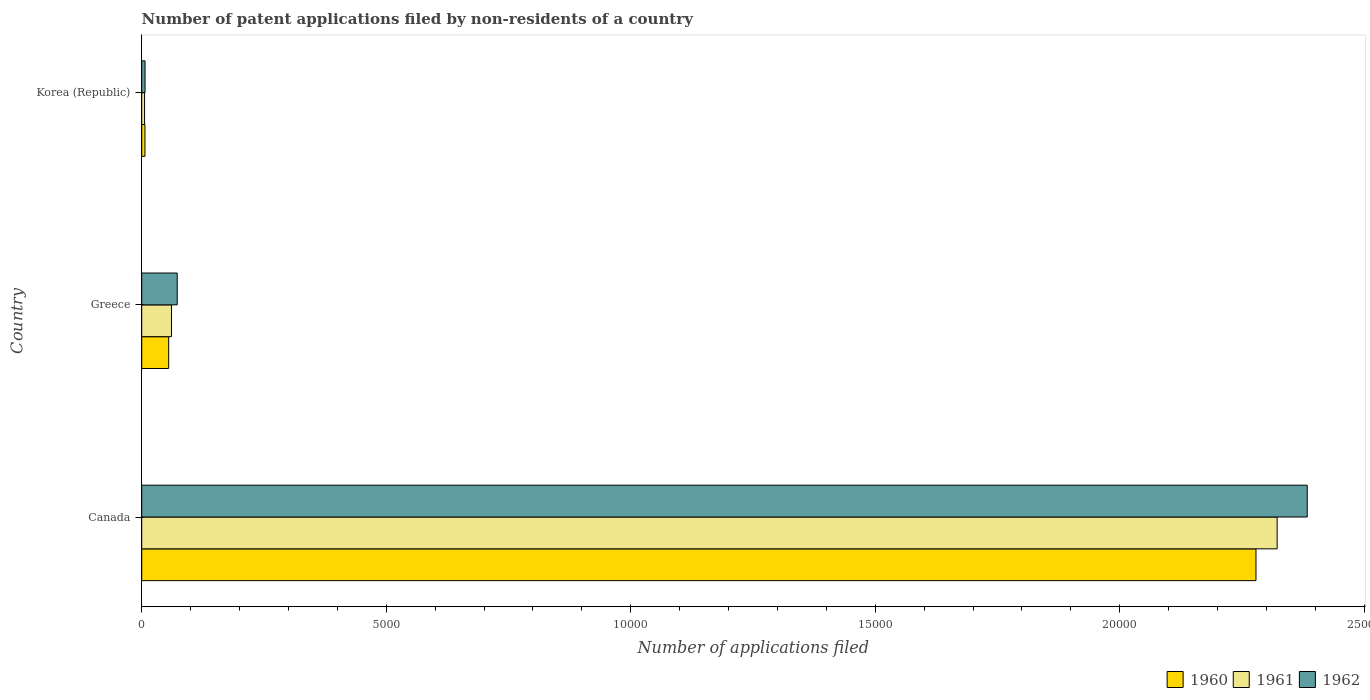Are the number of bars per tick equal to the number of legend labels?
Provide a short and direct response. Yes. How many bars are there on the 2nd tick from the bottom?
Ensure brevity in your answer.  3. What is the number of applications filed in 1961 in Greece?
Provide a succinct answer. 609. Across all countries, what is the maximum number of applications filed in 1960?
Offer a very short reply. 2.28e+04. In which country was the number of applications filed in 1961 minimum?
Keep it short and to the point. Korea (Republic). What is the total number of applications filed in 1962 in the graph?
Offer a terse response. 2.46e+04. What is the difference between the number of applications filed in 1960 in Canada and that in Korea (Republic)?
Your answer should be compact. 2.27e+04. What is the difference between the number of applications filed in 1961 in Canada and the number of applications filed in 1960 in Korea (Republic)?
Offer a terse response. 2.32e+04. What is the average number of applications filed in 1960 per country?
Your answer should be compact. 7801. What is the difference between the number of applications filed in 1961 and number of applications filed in 1962 in Korea (Republic)?
Offer a very short reply. -10. What is the ratio of the number of applications filed in 1962 in Canada to that in Greece?
Offer a very short reply. 32.83. What is the difference between the highest and the second highest number of applications filed in 1961?
Ensure brevity in your answer.  2.26e+04. What is the difference between the highest and the lowest number of applications filed in 1960?
Offer a terse response. 2.27e+04. What does the 1st bar from the top in Canada represents?
Offer a terse response. 1962. Are all the bars in the graph horizontal?
Make the answer very short. Yes. Does the graph contain grids?
Offer a terse response. No. How many legend labels are there?
Make the answer very short. 3. What is the title of the graph?
Your answer should be compact. Number of patent applications filed by non-residents of a country. Does "2004" appear as one of the legend labels in the graph?
Offer a terse response. No. What is the label or title of the X-axis?
Provide a succinct answer. Number of applications filed. What is the label or title of the Y-axis?
Keep it short and to the point. Country. What is the Number of applications filed of 1960 in Canada?
Your answer should be compact. 2.28e+04. What is the Number of applications filed in 1961 in Canada?
Make the answer very short. 2.32e+04. What is the Number of applications filed of 1962 in Canada?
Ensure brevity in your answer.  2.38e+04. What is the Number of applications filed of 1960 in Greece?
Give a very brief answer. 551. What is the Number of applications filed of 1961 in Greece?
Offer a very short reply. 609. What is the Number of applications filed of 1962 in Greece?
Keep it short and to the point. 726. What is the Number of applications filed in 1960 in Korea (Republic)?
Your answer should be compact. 66. What is the Number of applications filed of 1961 in Korea (Republic)?
Your answer should be very brief. 58. Across all countries, what is the maximum Number of applications filed in 1960?
Your response must be concise. 2.28e+04. Across all countries, what is the maximum Number of applications filed of 1961?
Offer a terse response. 2.32e+04. Across all countries, what is the maximum Number of applications filed of 1962?
Provide a succinct answer. 2.38e+04. Across all countries, what is the minimum Number of applications filed in 1960?
Your answer should be very brief. 66. Across all countries, what is the minimum Number of applications filed in 1962?
Provide a short and direct response. 68. What is the total Number of applications filed of 1960 in the graph?
Ensure brevity in your answer.  2.34e+04. What is the total Number of applications filed of 1961 in the graph?
Give a very brief answer. 2.39e+04. What is the total Number of applications filed in 1962 in the graph?
Make the answer very short. 2.46e+04. What is the difference between the Number of applications filed of 1960 in Canada and that in Greece?
Your answer should be very brief. 2.22e+04. What is the difference between the Number of applications filed in 1961 in Canada and that in Greece?
Provide a succinct answer. 2.26e+04. What is the difference between the Number of applications filed in 1962 in Canada and that in Greece?
Your response must be concise. 2.31e+04. What is the difference between the Number of applications filed in 1960 in Canada and that in Korea (Republic)?
Your answer should be very brief. 2.27e+04. What is the difference between the Number of applications filed of 1961 in Canada and that in Korea (Republic)?
Make the answer very short. 2.32e+04. What is the difference between the Number of applications filed in 1962 in Canada and that in Korea (Republic)?
Provide a succinct answer. 2.38e+04. What is the difference between the Number of applications filed of 1960 in Greece and that in Korea (Republic)?
Your answer should be compact. 485. What is the difference between the Number of applications filed of 1961 in Greece and that in Korea (Republic)?
Your response must be concise. 551. What is the difference between the Number of applications filed of 1962 in Greece and that in Korea (Republic)?
Offer a very short reply. 658. What is the difference between the Number of applications filed of 1960 in Canada and the Number of applications filed of 1961 in Greece?
Offer a very short reply. 2.22e+04. What is the difference between the Number of applications filed of 1960 in Canada and the Number of applications filed of 1962 in Greece?
Provide a short and direct response. 2.21e+04. What is the difference between the Number of applications filed of 1961 in Canada and the Number of applications filed of 1962 in Greece?
Make the answer very short. 2.25e+04. What is the difference between the Number of applications filed in 1960 in Canada and the Number of applications filed in 1961 in Korea (Republic)?
Your response must be concise. 2.27e+04. What is the difference between the Number of applications filed of 1960 in Canada and the Number of applications filed of 1962 in Korea (Republic)?
Offer a very short reply. 2.27e+04. What is the difference between the Number of applications filed of 1961 in Canada and the Number of applications filed of 1962 in Korea (Republic)?
Offer a very short reply. 2.32e+04. What is the difference between the Number of applications filed in 1960 in Greece and the Number of applications filed in 1961 in Korea (Republic)?
Provide a short and direct response. 493. What is the difference between the Number of applications filed of 1960 in Greece and the Number of applications filed of 1962 in Korea (Republic)?
Give a very brief answer. 483. What is the difference between the Number of applications filed of 1961 in Greece and the Number of applications filed of 1962 in Korea (Republic)?
Keep it short and to the point. 541. What is the average Number of applications filed of 1960 per country?
Make the answer very short. 7801. What is the average Number of applications filed of 1961 per country?
Offer a very short reply. 7962. What is the average Number of applications filed in 1962 per country?
Give a very brief answer. 8209.33. What is the difference between the Number of applications filed of 1960 and Number of applications filed of 1961 in Canada?
Your answer should be compact. -433. What is the difference between the Number of applications filed of 1960 and Number of applications filed of 1962 in Canada?
Offer a terse response. -1048. What is the difference between the Number of applications filed of 1961 and Number of applications filed of 1962 in Canada?
Ensure brevity in your answer.  -615. What is the difference between the Number of applications filed of 1960 and Number of applications filed of 1961 in Greece?
Provide a succinct answer. -58. What is the difference between the Number of applications filed in 1960 and Number of applications filed in 1962 in Greece?
Provide a succinct answer. -175. What is the difference between the Number of applications filed in 1961 and Number of applications filed in 1962 in Greece?
Your answer should be very brief. -117. What is the difference between the Number of applications filed in 1960 and Number of applications filed in 1961 in Korea (Republic)?
Your answer should be compact. 8. What is the difference between the Number of applications filed in 1960 and Number of applications filed in 1962 in Korea (Republic)?
Give a very brief answer. -2. What is the difference between the Number of applications filed of 1961 and Number of applications filed of 1962 in Korea (Republic)?
Provide a short and direct response. -10. What is the ratio of the Number of applications filed in 1960 in Canada to that in Greece?
Make the answer very short. 41.35. What is the ratio of the Number of applications filed in 1961 in Canada to that in Greece?
Ensure brevity in your answer.  38.13. What is the ratio of the Number of applications filed of 1962 in Canada to that in Greece?
Ensure brevity in your answer.  32.83. What is the ratio of the Number of applications filed in 1960 in Canada to that in Korea (Republic)?
Offer a very short reply. 345.24. What is the ratio of the Number of applications filed of 1961 in Canada to that in Korea (Republic)?
Make the answer very short. 400.33. What is the ratio of the Number of applications filed of 1962 in Canada to that in Korea (Republic)?
Offer a terse response. 350.5. What is the ratio of the Number of applications filed of 1960 in Greece to that in Korea (Republic)?
Make the answer very short. 8.35. What is the ratio of the Number of applications filed in 1961 in Greece to that in Korea (Republic)?
Give a very brief answer. 10.5. What is the ratio of the Number of applications filed in 1962 in Greece to that in Korea (Republic)?
Your response must be concise. 10.68. What is the difference between the highest and the second highest Number of applications filed of 1960?
Keep it short and to the point. 2.22e+04. What is the difference between the highest and the second highest Number of applications filed in 1961?
Offer a very short reply. 2.26e+04. What is the difference between the highest and the second highest Number of applications filed of 1962?
Offer a terse response. 2.31e+04. What is the difference between the highest and the lowest Number of applications filed in 1960?
Keep it short and to the point. 2.27e+04. What is the difference between the highest and the lowest Number of applications filed of 1961?
Your answer should be compact. 2.32e+04. What is the difference between the highest and the lowest Number of applications filed of 1962?
Provide a short and direct response. 2.38e+04. 